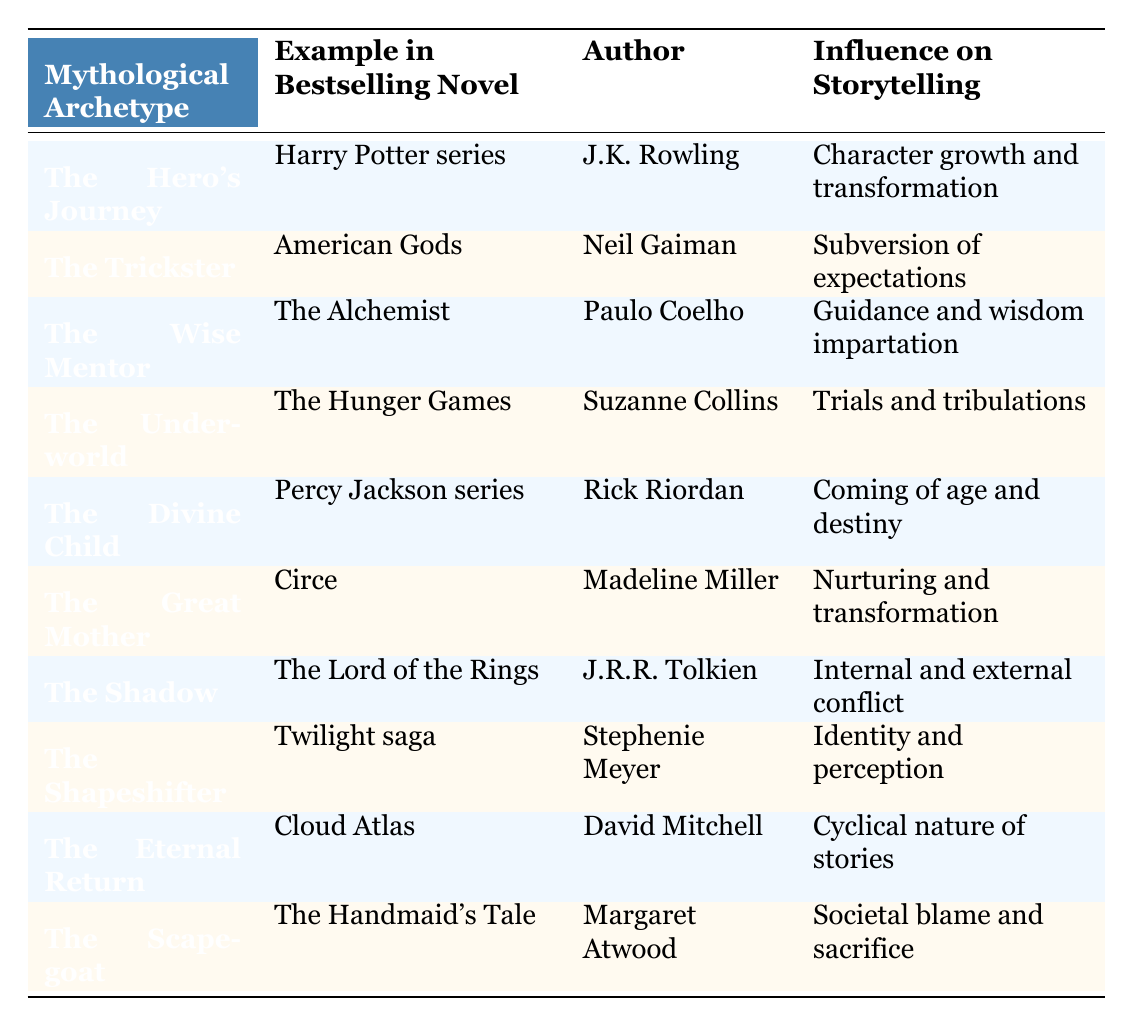What is the example of the Hero's Journey archetype? The table shows that the example of the Hero's Journey archetype is the Harry Potter series, authored by J.K. Rowling.
Answer: Harry Potter series Which author wrote about The Trickster archetype? According to the table, Neil Gaiman is the author who wrote about The Trickster archetype in the bestselling novel American Gods.
Answer: Neil Gaiman Does The Shadow archetype focus on internal conflict? The table indicates that The Shadow, as seen in The Lord of the Rings by J.R.R. Tolkien, involves internal and external conflict, which confirms that it indeed focuses on internal conflict.
Answer: Yes What influences on storytelling does The Great Mother archetype provide? The table states that The Great Mother archetype, represented by Madeline Miller's Circe, provides nurturing and transformation as its influence on storytelling.
Answer: Nurturing and transformation Which archetype is linked to societal blame and sacrifice, and who is the author? The table relates the Scapegoat archetype to societal blame and sacrifice, with The Handmaid's Tale being the example by Margaret Atwood.
Answer: Scapegoat; Margaret Atwood What is the influence on storytelling of The Divine Child archetype? The table specifies that The Divine Child archetype, seen in the Percy Jackson series by Rick Riordan, influences storytelling through themes of coming of age and destiny.
Answer: Coming of age and destiny Which two archetypes are focused on guidance and transformation? By examining the table, The Wise Mentor and The Great Mother are the two archetypes focused on guidance and transformation, with Paulo Coelho's The Alchemist emphasizing guidance, and Madeline Miller's Circe emphasizing transformation.
Answer: The Wise Mentor and The Great Mother How many archetypes in the table are associated with a series of novels? Looking at the table, there are three archetypes associated with a series of novels: The Hero's Journey (Harry Potter series), The Divine Child (Percy Jackson series), and The Shapeshifter (Twilight saga), totaling three such archetypes.
Answer: Three Is the influence of The Eternal Return more about a cyclical nature than linear progression? The table shows that The Eternal Return, as represented in Cloud Atlas by David Mitchell, focuses on the cyclical nature of stories, which implies a contrast to linear progression.
Answer: Yes 